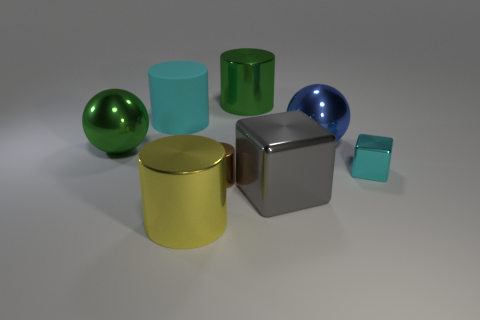If this were a real-world setup, what material would you guess each object is made from? Based on the visual cues, the green and blue glossy spheres and the transparent objects appear to be made of a kind of glass or polished stone, due to their high reflectivity and clarity. The golden and silver objects with a metallic sheen could be made of polished metal. The matte blue object, which doesn't reflect much light, might be made of a ceramic or plastic material with a paint finish that diffuses light rather than reflecting it. 